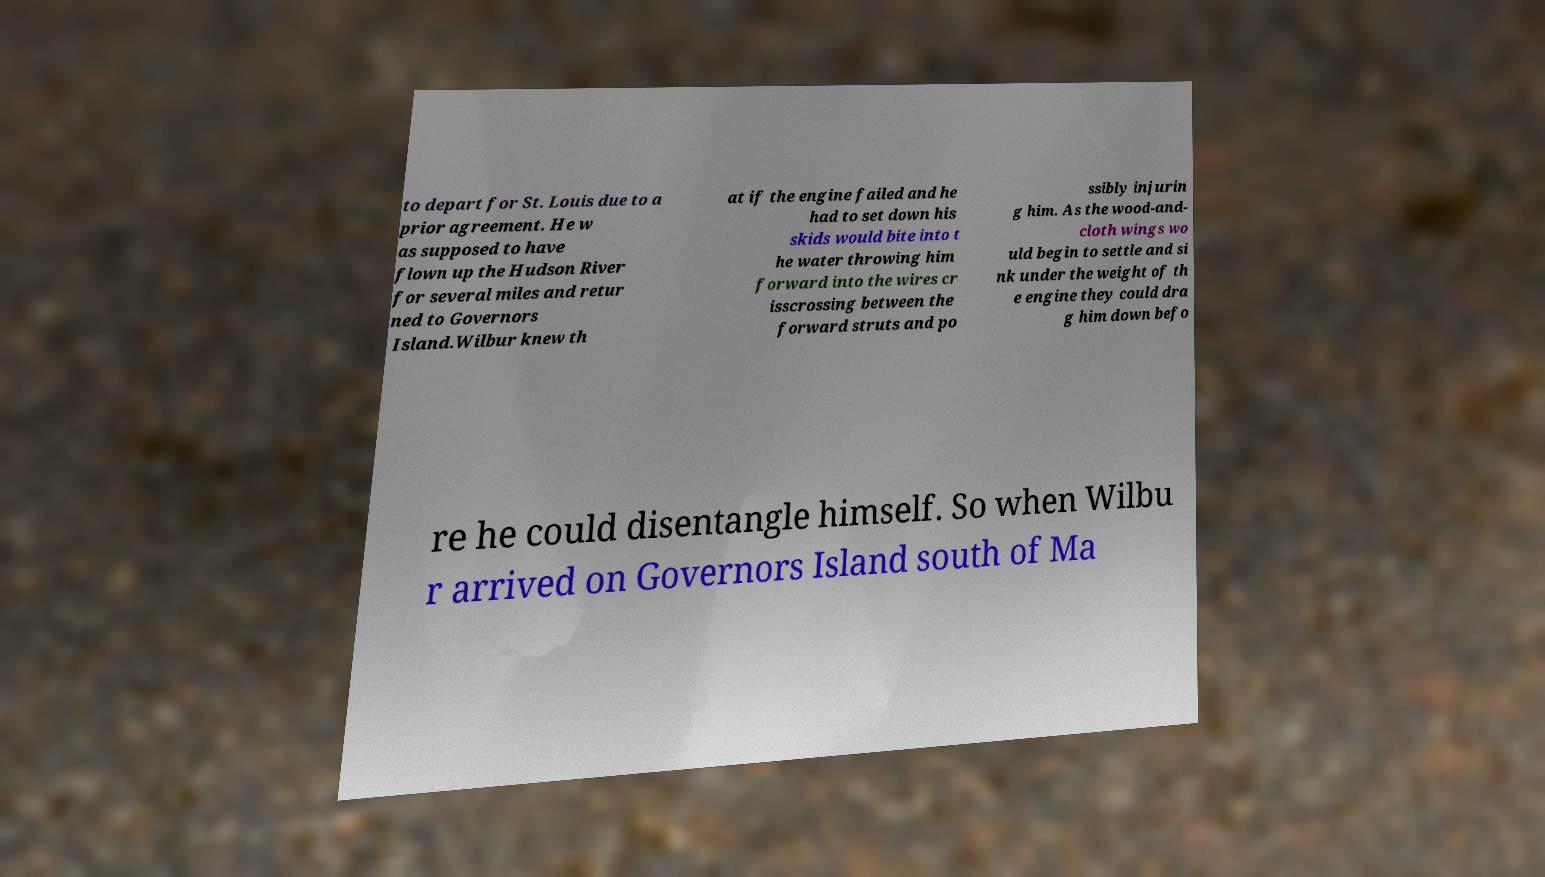Please identify and transcribe the text found in this image. to depart for St. Louis due to a prior agreement. He w as supposed to have flown up the Hudson River for several miles and retur ned to Governors Island.Wilbur knew th at if the engine failed and he had to set down his skids would bite into t he water throwing him forward into the wires cr isscrossing between the forward struts and po ssibly injurin g him. As the wood-and- cloth wings wo uld begin to settle and si nk under the weight of th e engine they could dra g him down befo re he could disentangle himself. So when Wilbu r arrived on Governors Island south of Ma 